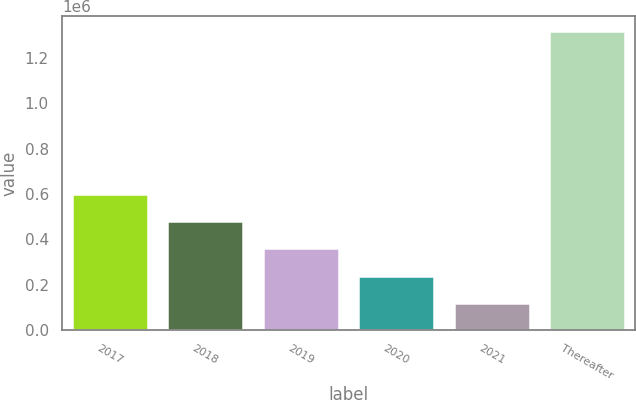Convert chart. <chart><loc_0><loc_0><loc_500><loc_500><bar_chart><fcel>2017<fcel>2018<fcel>2019<fcel>2020<fcel>2021<fcel>Thereafter<nl><fcel>599118<fcel>479206<fcel>359293<fcel>239381<fcel>119469<fcel>1.31859e+06<nl></chart> 